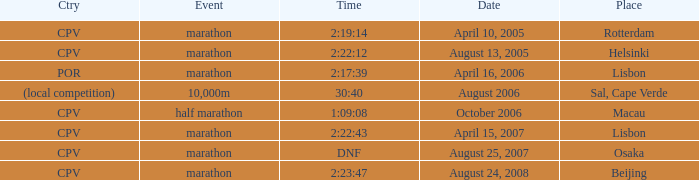What is the Date of the Event with a Time of 2:23:47? August 24, 2008. 